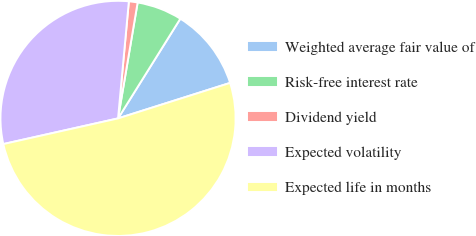<chart> <loc_0><loc_0><loc_500><loc_500><pie_chart><fcel>Weighted average fair value of<fcel>Risk-free interest rate<fcel>Dividend yield<fcel>Expected volatility<fcel>Expected life in months<nl><fcel>11.23%<fcel>6.22%<fcel>1.2%<fcel>29.97%<fcel>51.38%<nl></chart> 